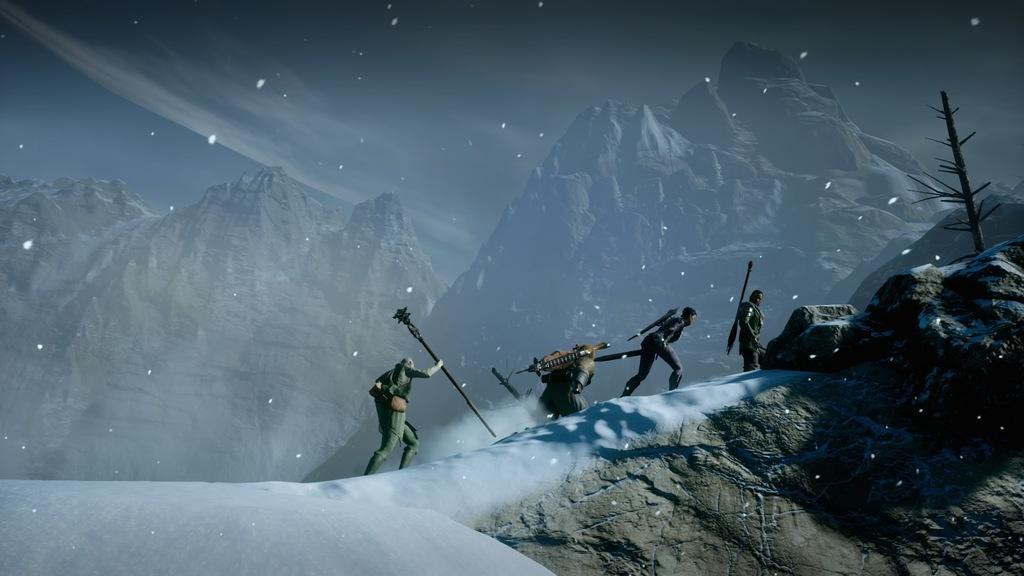Could you give a brief overview of what you see in this image? In this picture we can see a graphical image, here we can see some people on snow and in the background we can see mountains. 